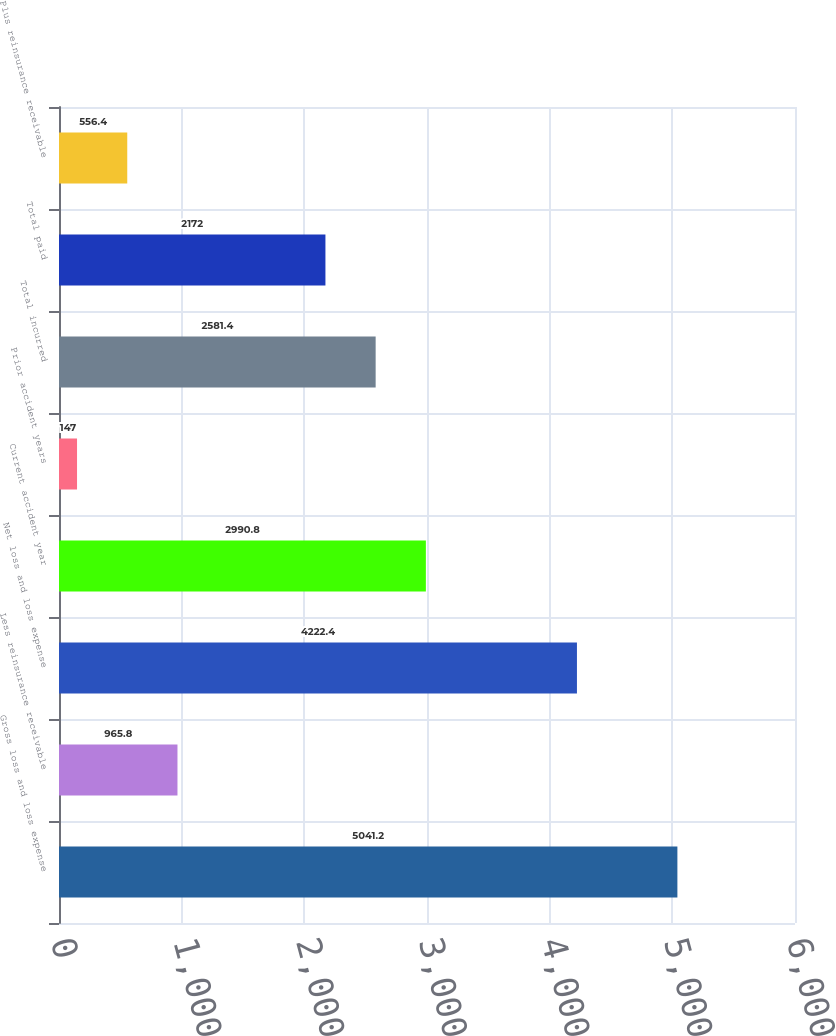Convert chart to OTSL. <chart><loc_0><loc_0><loc_500><loc_500><bar_chart><fcel>Gross loss and loss expense<fcel>Less reinsurance receivable<fcel>Net loss and loss expense<fcel>Current accident year<fcel>Prior accident years<fcel>Total incurred<fcel>Total paid<fcel>Plus reinsurance receivable<nl><fcel>5041.2<fcel>965.8<fcel>4222.4<fcel>2990.8<fcel>147<fcel>2581.4<fcel>2172<fcel>556.4<nl></chart> 